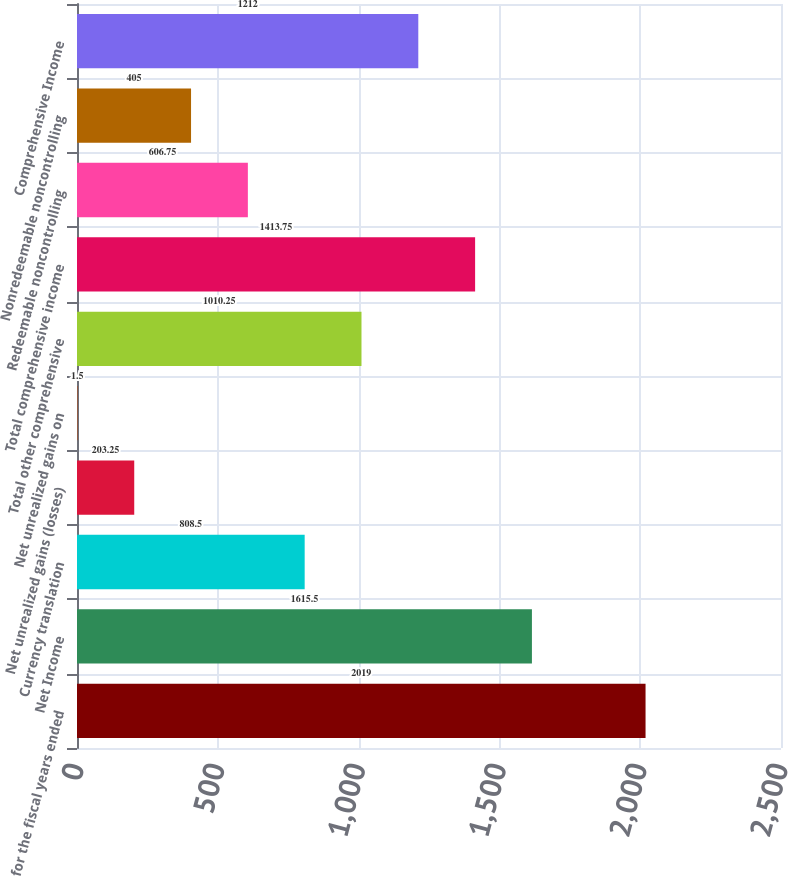<chart> <loc_0><loc_0><loc_500><loc_500><bar_chart><fcel>for the fiscal years ended<fcel>Net Income<fcel>Currency translation<fcel>Net unrealized gains (losses)<fcel>Net unrealized gains on<fcel>Total other comprehensive<fcel>Total comprehensive income<fcel>Redeemable noncontrolling<fcel>Nonredeemable noncontrolling<fcel>Comprehensive Income<nl><fcel>2019<fcel>1615.5<fcel>808.5<fcel>203.25<fcel>1.5<fcel>1010.25<fcel>1413.75<fcel>606.75<fcel>405<fcel>1212<nl></chart> 